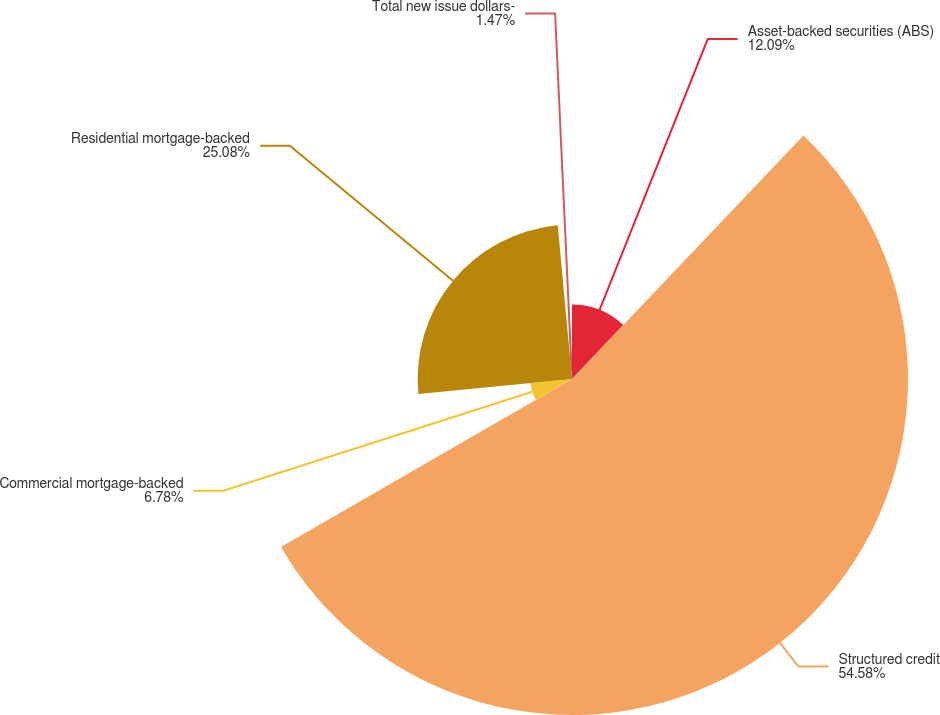<chart> <loc_0><loc_0><loc_500><loc_500><pie_chart><fcel>Asset-backed securities (ABS)<fcel>Structured credit<fcel>Commercial mortgage-backed<fcel>Residential mortgage-backed<fcel>Total new issue dollars-<nl><fcel>12.09%<fcel>54.57%<fcel>6.78%<fcel>25.07%<fcel>1.47%<nl></chart> 